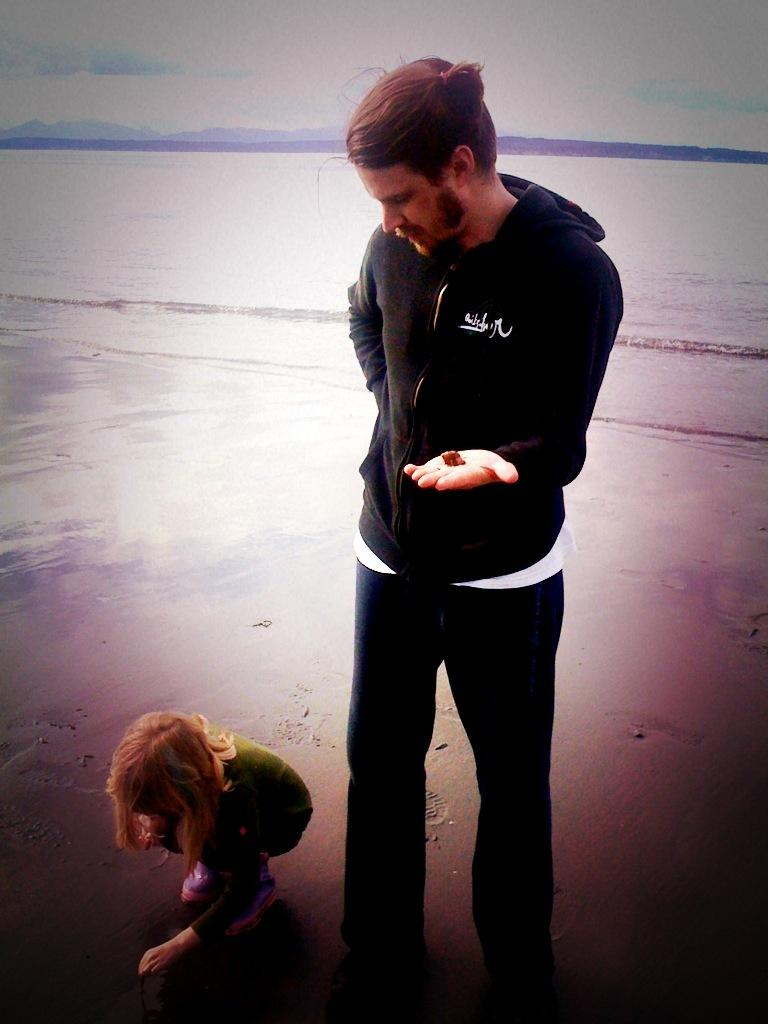What is the man in the image doing? The man is standing in the image. What is the man wearing? The man is wearing a black jacket. What is the girl in the image doing? The girl is sitting on the sand in the image. What can be seen in the background of the image? There is water visible in the background of the image. What is visible in the sky in the image? The sky is visible in the image. How many snakes are crawling on the chair in the image? There is no chair or snakes present in the image. What is the time duration of the minute shown in the image? There is no time duration or minute shown in the image. 